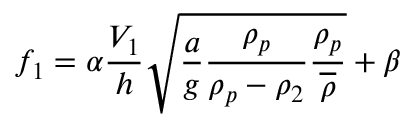Convert formula to latex. <formula><loc_0><loc_0><loc_500><loc_500>f _ { 1 } = \alpha \frac { V _ { 1 } } { h } \sqrt { \frac { a } { g } \frac { \rho _ { p } } { \rho _ { p } - \rho _ { 2 } } \frac { \rho _ { p } } { \overline { \rho } } } + \beta</formula> 